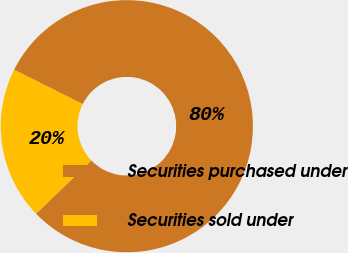<chart> <loc_0><loc_0><loc_500><loc_500><pie_chart><fcel>Securities purchased under<fcel>Securities sold under<nl><fcel>80.41%<fcel>19.59%<nl></chart> 